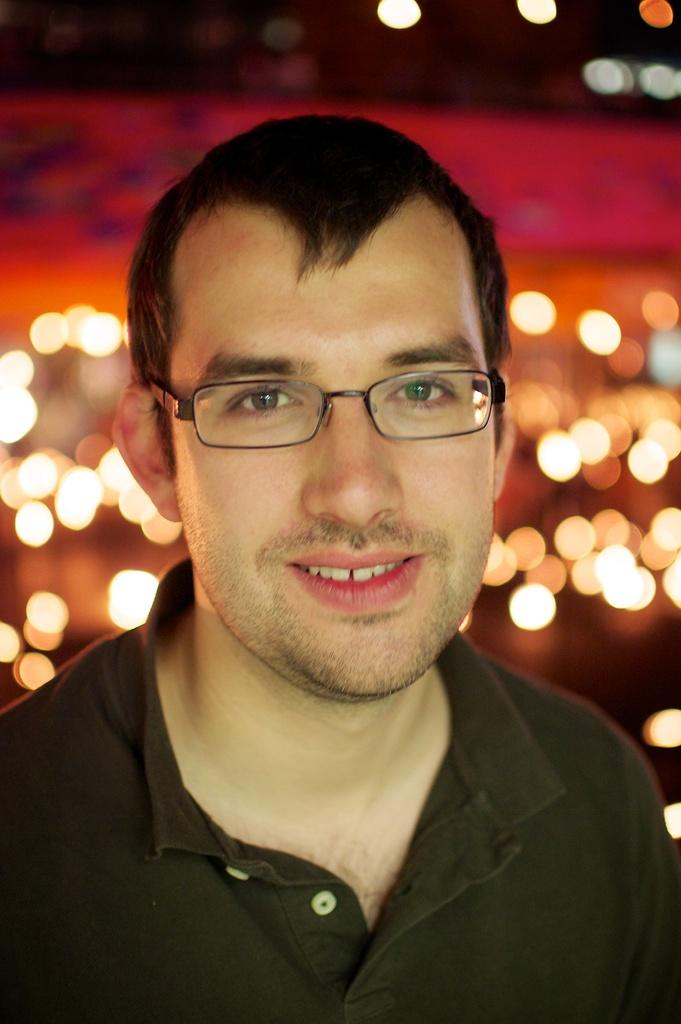What is present in the image? There is a person in the image. How is the person's expression in the image? The person is smiling. What can be seen in the background of the image? There are lights visible in the background of the image. What type of bird is perched on the vase in the image? There is no bird or vase present in the image. What type of vessel is being used by the person in the image? The image does not show any vessels being used by the person. 